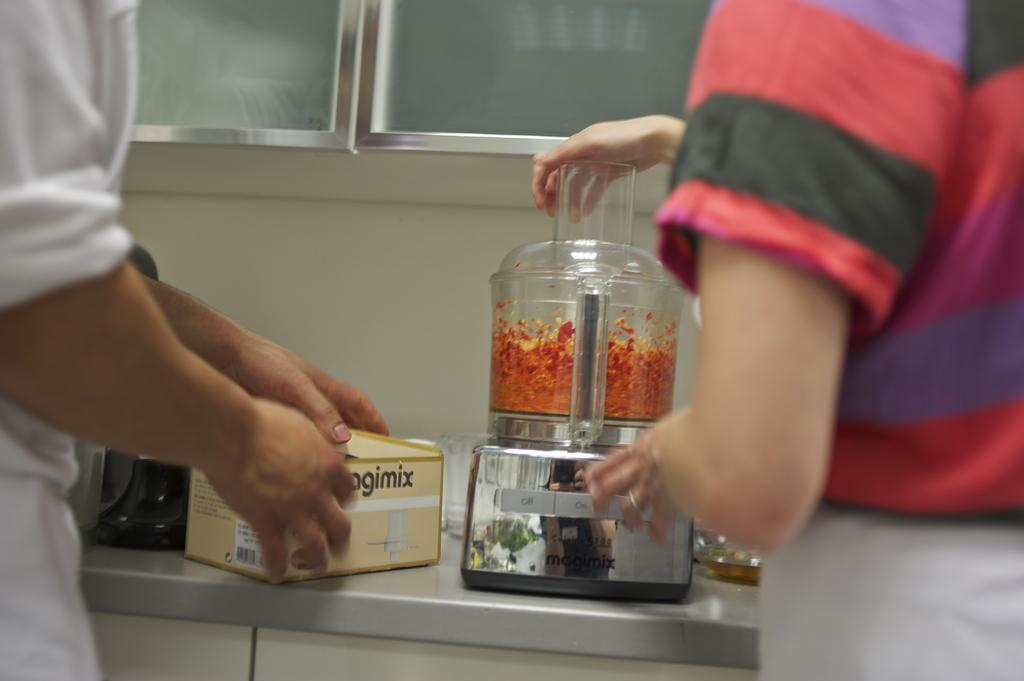<image>
Create a compact narrative representing the image presented. people trying out a blender named Magimix in a white kitchen 